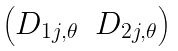<formula> <loc_0><loc_0><loc_500><loc_500>\begin{pmatrix} D _ { 1 j , \theta } & D _ { 2 j , \theta } \end{pmatrix}</formula> 